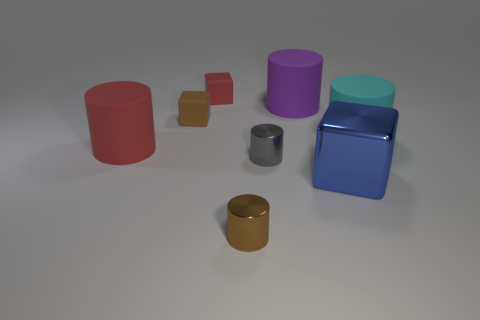Subtract all tiny shiny cylinders. How many cylinders are left? 3 Add 1 large red matte blocks. How many objects exist? 9 Subtract all purple cylinders. How many cylinders are left? 4 Subtract 2 cubes. How many cubes are left? 1 Subtract all gray spheres. How many red blocks are left? 1 Subtract all big purple things. Subtract all brown rubber objects. How many objects are left? 6 Add 4 purple rubber cylinders. How many purple rubber cylinders are left? 5 Add 2 big red metal cylinders. How many big red metal cylinders exist? 2 Subtract 0 green balls. How many objects are left? 8 Subtract all cylinders. How many objects are left? 3 